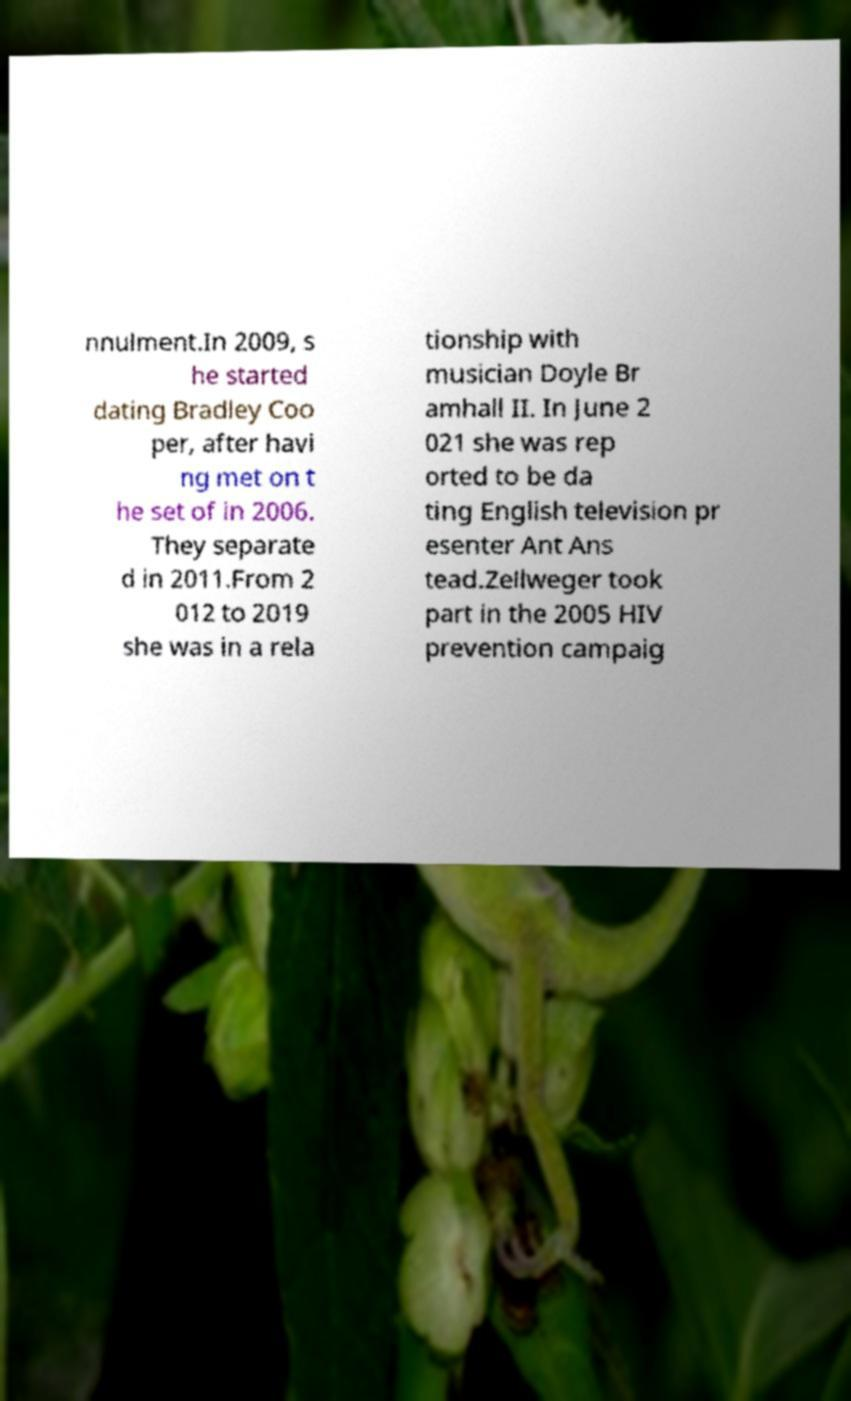I need the written content from this picture converted into text. Can you do that? nnulment.In 2009, s he started dating Bradley Coo per, after havi ng met on t he set of in 2006. They separate d in 2011.From 2 012 to 2019 she was in a rela tionship with musician Doyle Br amhall II. In June 2 021 she was rep orted to be da ting English television pr esenter Ant Ans tead.Zellweger took part in the 2005 HIV prevention campaig 